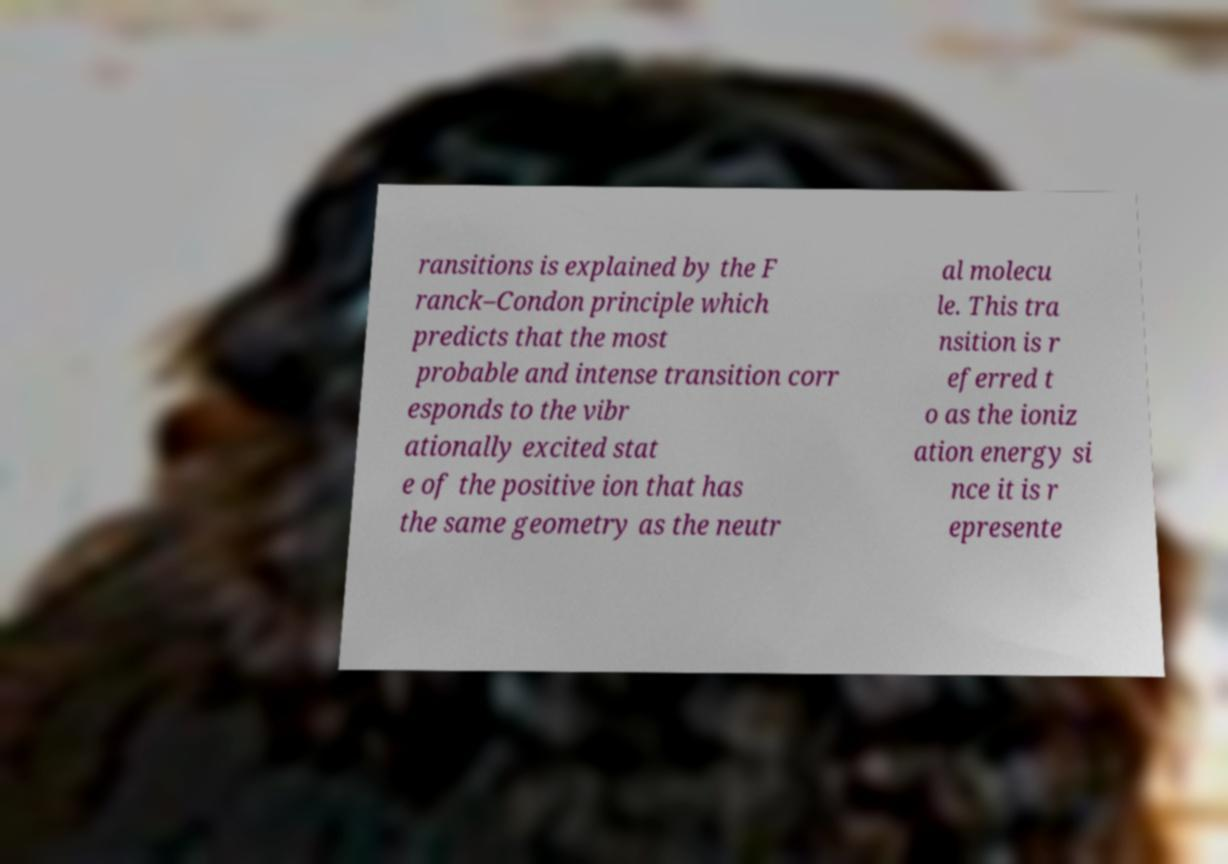For documentation purposes, I need the text within this image transcribed. Could you provide that? ransitions is explained by the F ranck–Condon principle which predicts that the most probable and intense transition corr esponds to the vibr ationally excited stat e of the positive ion that has the same geometry as the neutr al molecu le. This tra nsition is r eferred t o as the ioniz ation energy si nce it is r epresente 